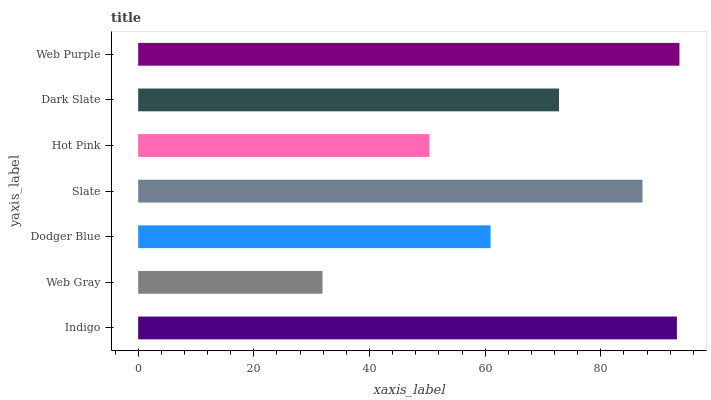Is Web Gray the minimum?
Answer yes or no. Yes. Is Web Purple the maximum?
Answer yes or no. Yes. Is Dodger Blue the minimum?
Answer yes or no. No. Is Dodger Blue the maximum?
Answer yes or no. No. Is Dodger Blue greater than Web Gray?
Answer yes or no. Yes. Is Web Gray less than Dodger Blue?
Answer yes or no. Yes. Is Web Gray greater than Dodger Blue?
Answer yes or no. No. Is Dodger Blue less than Web Gray?
Answer yes or no. No. Is Dark Slate the high median?
Answer yes or no. Yes. Is Dark Slate the low median?
Answer yes or no. Yes. Is Indigo the high median?
Answer yes or no. No. Is Web Purple the low median?
Answer yes or no. No. 